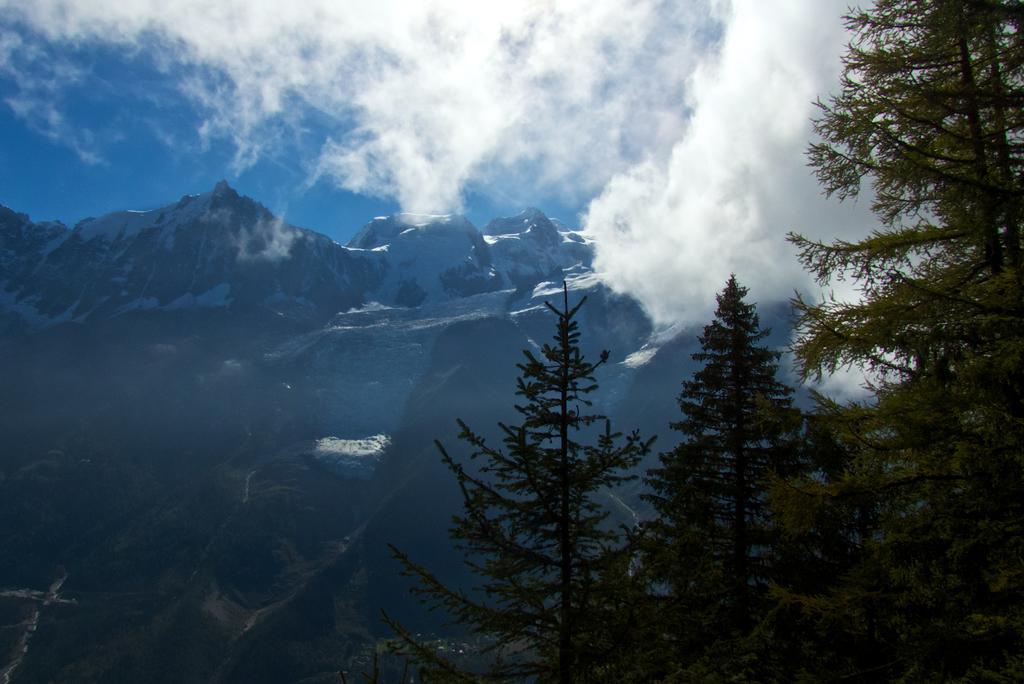Describe this image in one or two sentences. In the picture there are many trees and behind the trees there are tall mountains. 